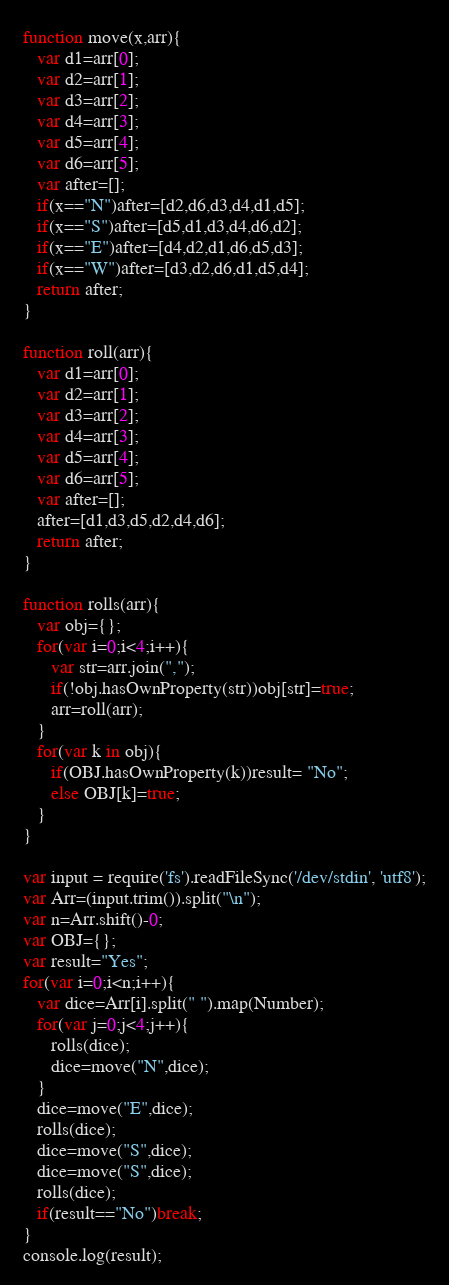<code> <loc_0><loc_0><loc_500><loc_500><_JavaScript_>function move(x,arr){
   var d1=arr[0];
   var d2=arr[1];
   var d3=arr[2];
   var d4=arr[3];
   var d5=arr[4];
   var d6=arr[5];
   var after=[];
   if(x=="N")after=[d2,d6,d3,d4,d1,d5];
   if(x=="S")after=[d5,d1,d3,d4,d6,d2];
   if(x=="E")after=[d4,d2,d1,d6,d5,d3];
   if(x=="W")after=[d3,d2,d6,d1,d5,d4];
   return after;
}

function roll(arr){
   var d1=arr[0];
   var d2=arr[1];
   var d3=arr[2];
   var d4=arr[3];
   var d5=arr[4];
   var d6=arr[5];
   var after=[];
   after=[d1,d3,d5,d2,d4,d6];
   return after;
}

function rolls(arr){
   var obj={};
   for(var i=0;i<4;i++){
      var str=arr.join(",");
      if(!obj.hasOwnProperty(str))obj[str]=true;
      arr=roll(arr);
   }
   for(var k in obj){
      if(OBJ.hasOwnProperty(k))result= "No";
      else OBJ[k]=true;
   }
}

var input = require('fs').readFileSync('/dev/stdin', 'utf8');
var Arr=(input.trim()).split("\n");
var n=Arr.shift()-0;
var OBJ={};
var result="Yes";
for(var i=0;i<n;i++){
   var dice=Arr[i].split(" ").map(Number);
   for(var j=0;j<4;j++){
      rolls(dice);
      dice=move("N",dice);
   }
   dice=move("E",dice);
   rolls(dice);
   dice=move("S",dice);
   dice=move("S",dice);
   rolls(dice);
   if(result=="No")break;
}
console.log(result);</code> 